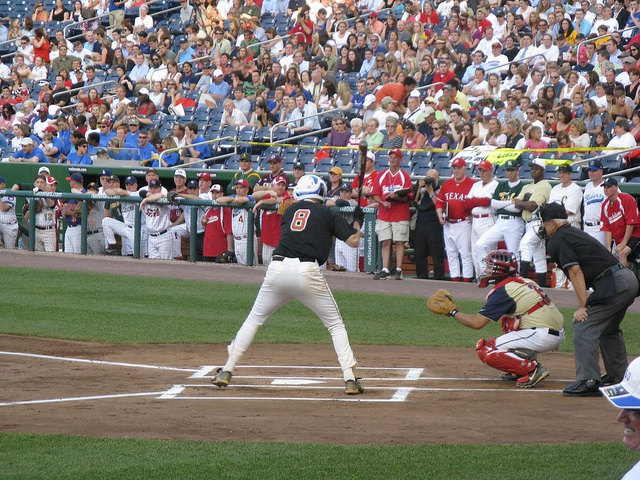Describe the objects in this image and their specific colors. I can see people in blue, gray, darkgray, and lightgray tones, people in blue, lightgray, black, darkgray, and gray tones, people in blue, black, gray, and purple tones, people in blue, darkgray, black, and gray tones, and people in blue, brown, darkgray, and gray tones in this image. 